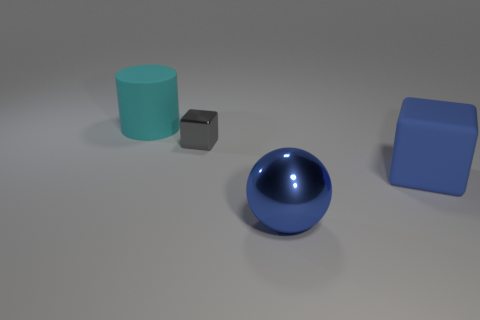Is the number of cyan matte objects that are in front of the tiny gray object less than the number of cubes? Indeed, the number of cyan matte objects in front of the tiny gray object, which counts as one, is less than the number of cubes present, as there is only one cube in the scene. 